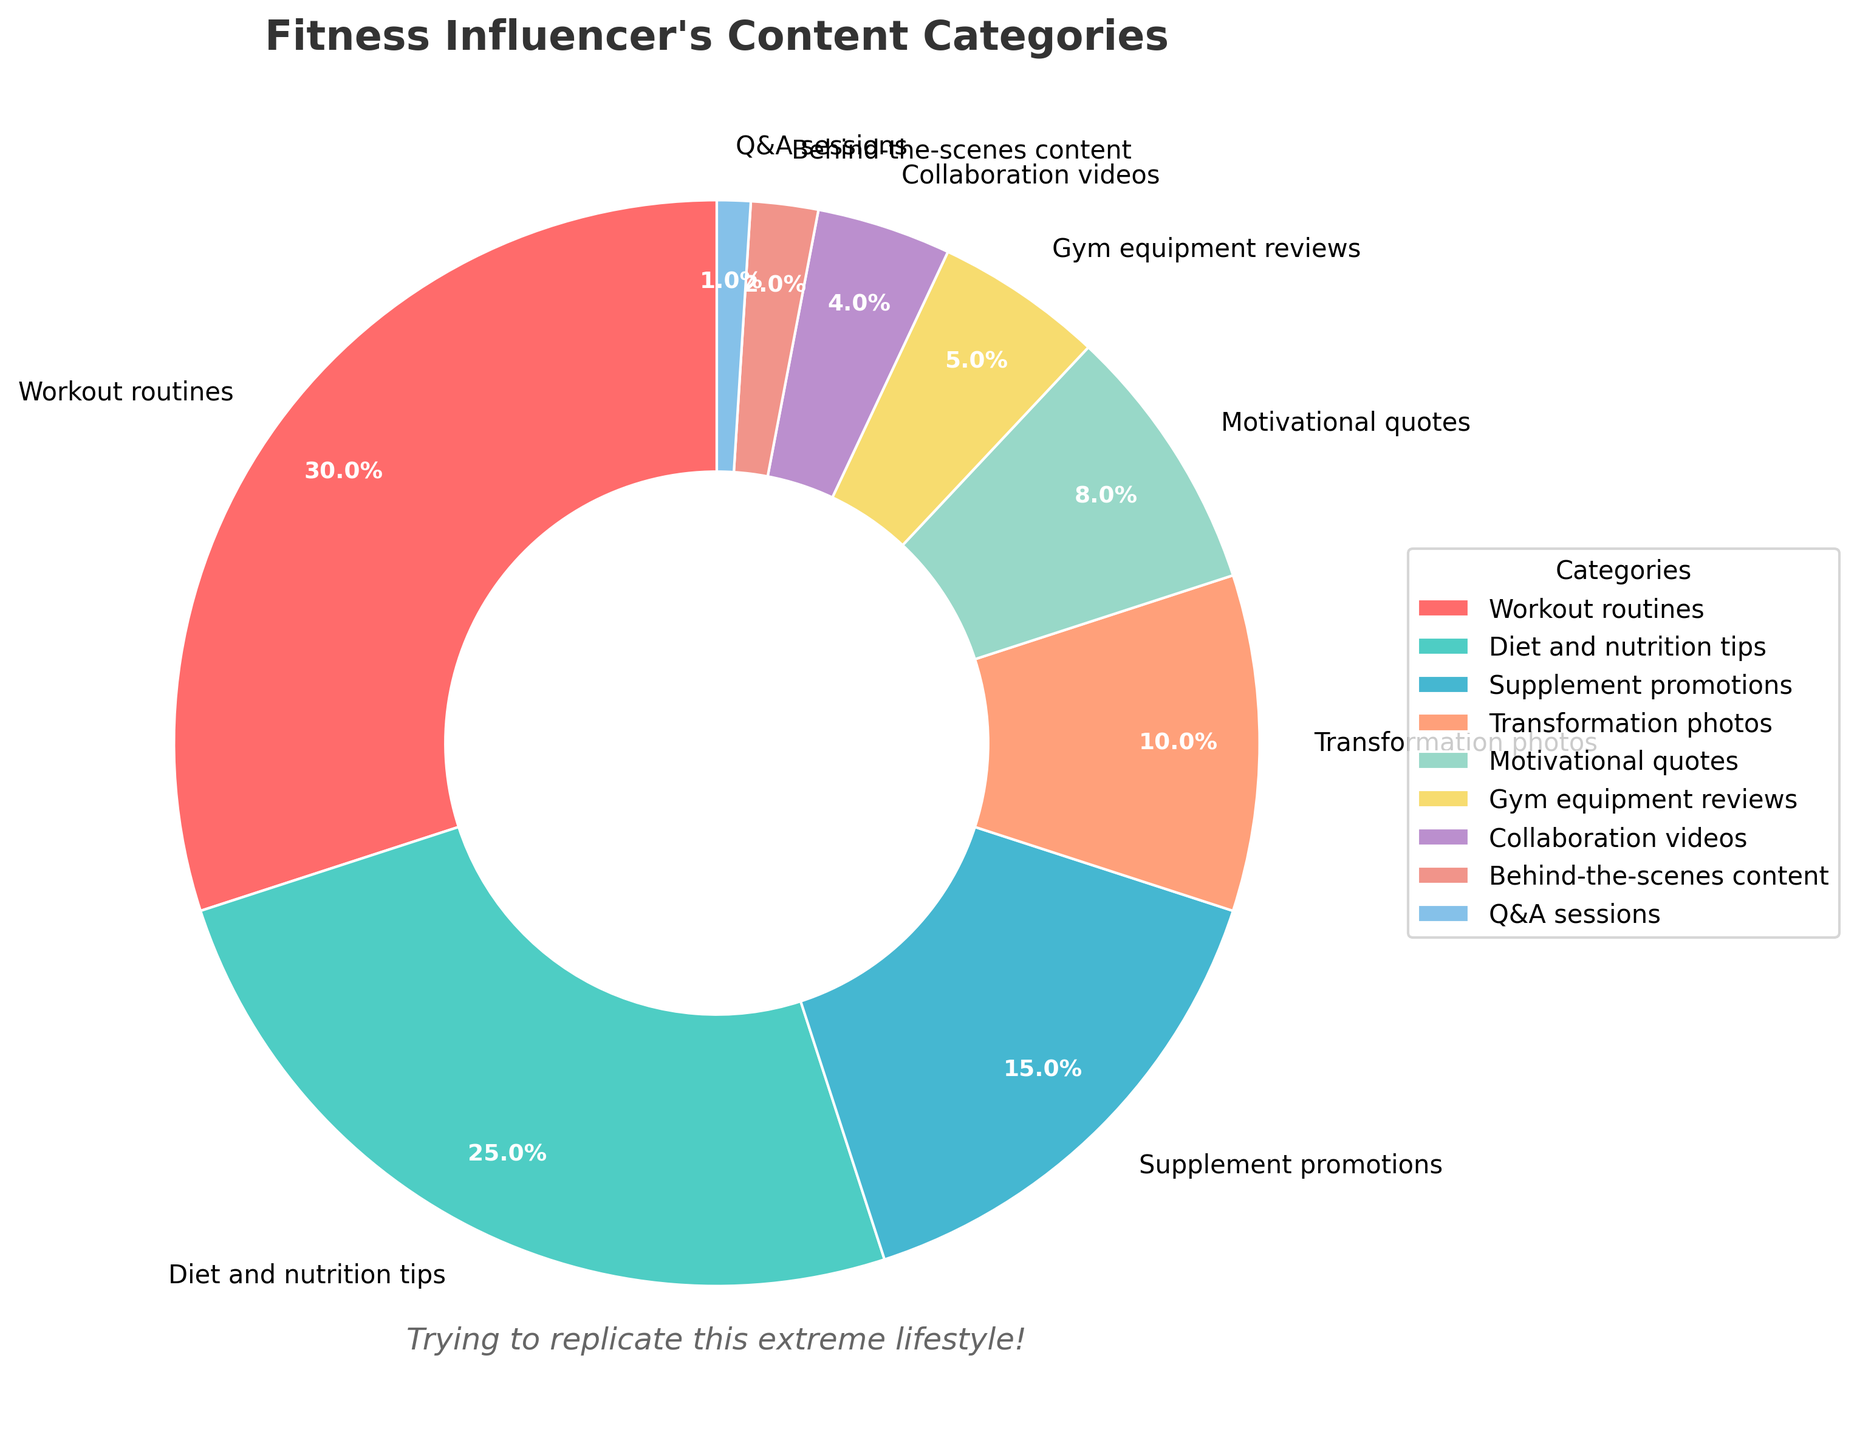What's the largest content category in the influencer's social media? The largest content category is represented by the biggest section of the pie chart, which is "Workout routines" at 30%.
Answer: Workout routines How much more percentage do motivational quotes make up compared to Q&A sessions? Motivational quotes constitute 8% of the total content, and Q&A sessions make up 1%. The difference in their percentages is 8% - 1% = 7%.
Answer: 7% Which content category comes after diet and nutrition tips in size? The segment after "Diet and nutrition tips" (25%) in terms of size is "Supplement promotions" at 15%.
Answer: Supplement promotions What is the combined percentage of workout routines and transformation photos? Adding the percentages of "Workout routines" (30%) and "Transformation photos" (10%) gives 30% + 10% = 40%.
Answer: 40% Is the percentage of gym equipment reviews more than behind-the-scenes content? Yes, gym equipment reviews constitute 5% whereas behind-the-scenes content makes up only 2%. 5% > 2%.
Answer: Yes What are the two smallest content categories on the influencer's social media? The smallest content categories, represented by the smallest pie sections, are "Behind-the-scenes content" (2%) and "Q&A sessions" (1%).
Answer: Behind-the-scenes content and Q&A sessions How do the percentages of transformation photos and collaboration videos compare? Transformation photos account for 10% and collaboration videos account for 4%. Hence, transformation photos have a higher percentage.
Answer: Transformation photos What is the total percentage of all categories related to visual content (transformation photos, behind-the-scenes content)? Adding the percentages of "Transformation photos" (10%) and "Behind-the-scenes content" (2%) gives 10% + 2% = 12%.
Answer: 12% Which category has a segment represented in blue, and what percentage does it have? The segment in blue corresponds to "Diet and nutrition tips," which represents 25% of the content.
Answer: Diet and nutrition tips, 25% What is the average percentage of the top three content categories? The top three categories are "Workout routines" (30%), "Diet and nutrition tips" (25%), and "Supplement promotions" (15%). The average is calculated as (30% + 25% + 15%) / 3 = 70% / 3 ≈ 23.33%.
Answer: 23.33% 